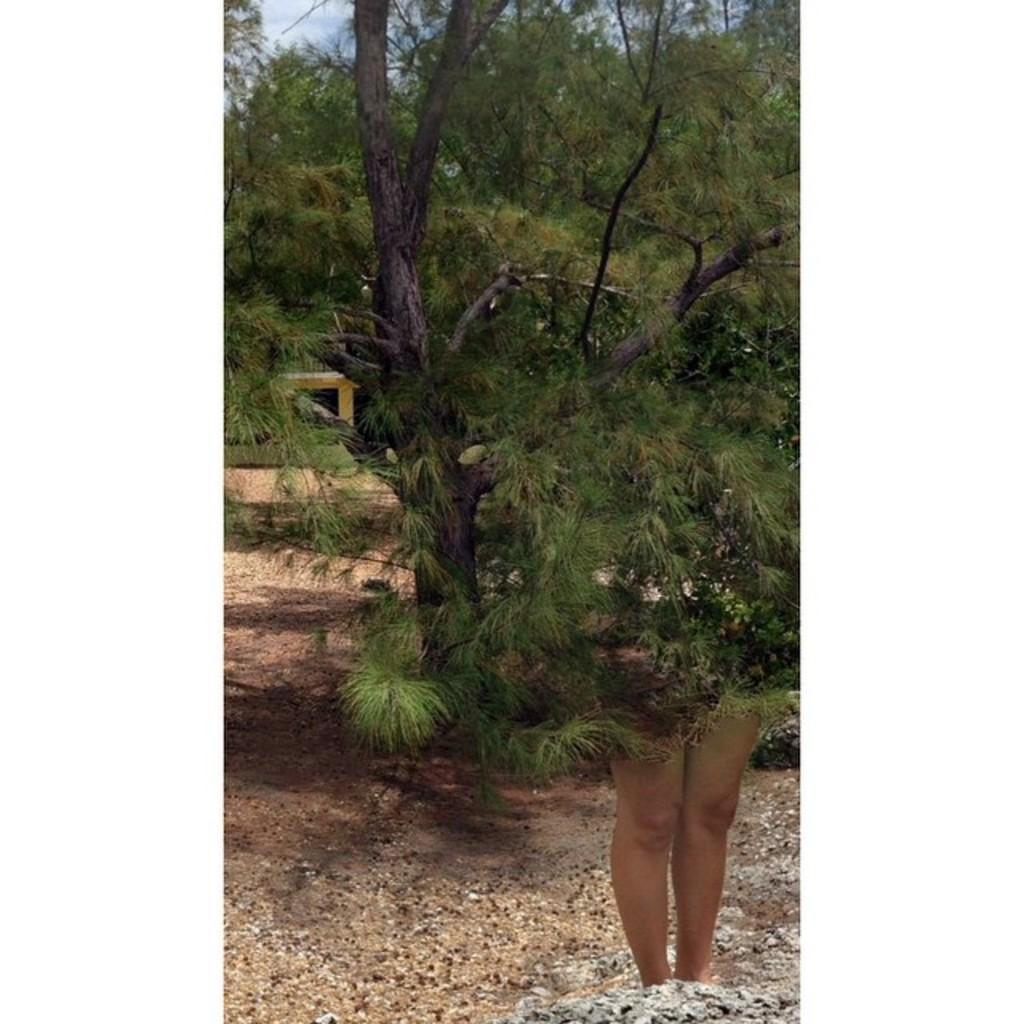Describe this image in one or two sentences. Here we can see legs of a person. There are trees. In the background we can see sky. 